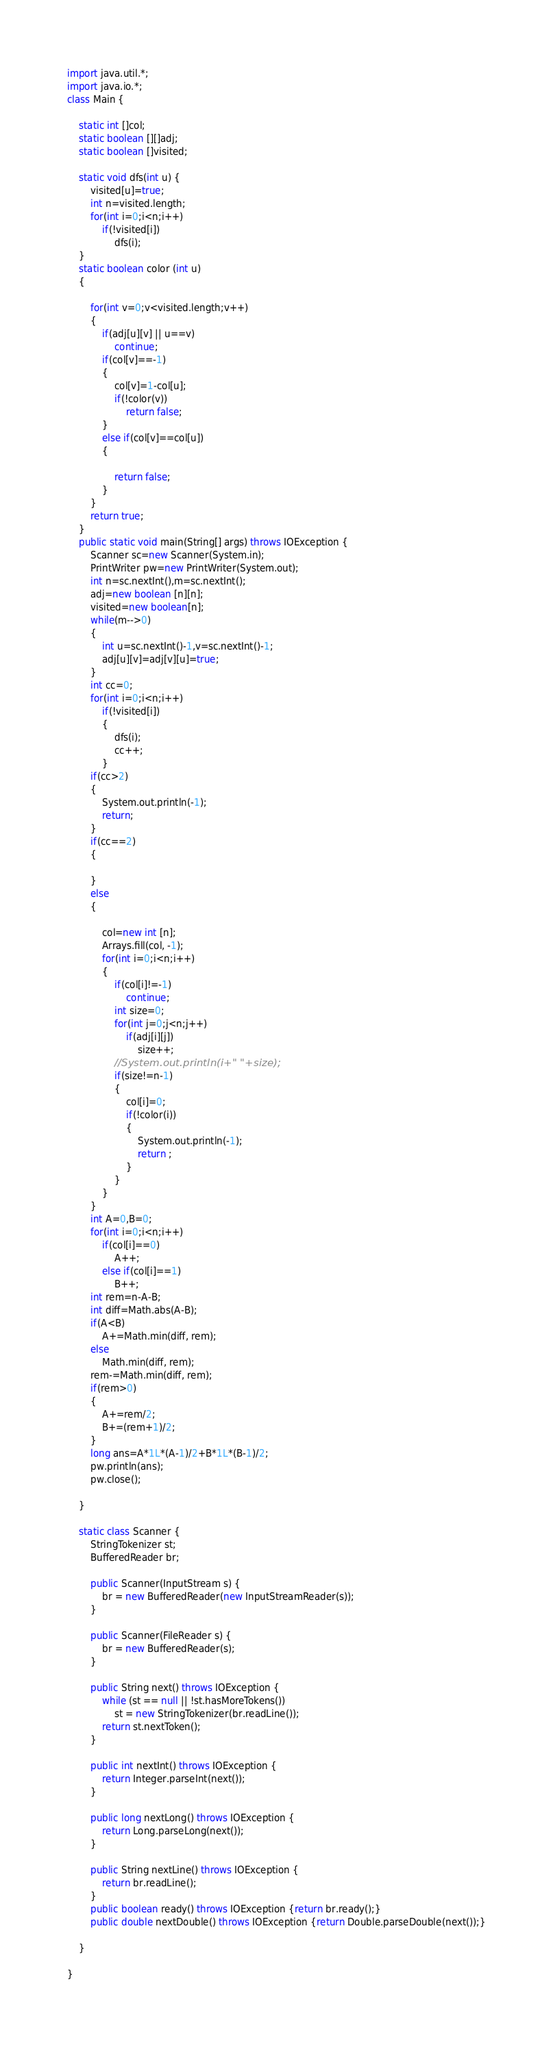Convert code to text. <code><loc_0><loc_0><loc_500><loc_500><_Java_>import java.util.*;
import java.io.*;
class Main {

	static int []col;
	static boolean [][]adj;
	static boolean []visited;
	
	static void dfs(int u) {
		visited[u]=true;
		int n=visited.length;
		for(int i=0;i<n;i++)
			if(!visited[i])
				dfs(i);
	}
	static boolean color (int u)
	{
		
		for(int v=0;v<visited.length;v++)
		{
			if(adj[u][v] || u==v)
				continue;
			if(col[v]==-1)
			{
				col[v]=1-col[u];
				if(!color(v))
					return false;
			}
			else if(col[v]==col[u])
			{
				
				return false;
			}	
		}
		return true;
	}
	public static void main(String[] args) throws IOException {
		Scanner sc=new Scanner(System.in);
		PrintWriter pw=new PrintWriter(System.out);
		int n=sc.nextInt(),m=sc.nextInt();
		adj=new boolean [n][n];
		visited=new boolean[n];
		while(m-->0)
		{
			int u=sc.nextInt()-1,v=sc.nextInt()-1;
			adj[u][v]=adj[v][u]=true;
		}
		int cc=0;
		for(int i=0;i<n;i++)
			if(!visited[i])
			{
				dfs(i);
				cc++;
			}
		if(cc>2)
		{
			System.out.println(-1);
			return;
		}
		if(cc==2)
		{
			
		}
		else
		{
			
			col=new int [n];
			Arrays.fill(col, -1);
			for(int i=0;i<n;i++)
			{
				if(col[i]!=-1)
					continue;
				int size=0;
				for(int j=0;j<n;j++)
					if(adj[i][j])
						size++;
				//System.out.println(i+" "+size);
				if(size!=n-1)
				{
					col[i]=0;
					if(!color(i))
					{
						System.out.println(-1);
						return ;
					}
				}
			}
		}
		int A=0,B=0;
		for(int i=0;i<n;i++)
			if(col[i]==0)
				A++;
			else if(col[i]==1)
				B++;
		int rem=n-A-B;
		int diff=Math.abs(A-B);
		if(A<B)
			A+=Math.min(diff, rem);
		else
			Math.min(diff, rem);
		rem-=Math.min(diff, rem);
		if(rem>0)
		{
			A+=rem/2;
			B+=(rem+1)/2;
		}
		long ans=A*1L*(A-1)/2+B*1L*(B-1)/2;
		pw.println(ans);
		pw.close();
		
	}
	
	static class Scanner {
        StringTokenizer st;
        BufferedReader br;
 
        public Scanner(InputStream s) {
            br = new BufferedReader(new InputStreamReader(s));
        }
 
        public Scanner(FileReader s) {
            br = new BufferedReader(s);
        }
 
        public String next() throws IOException {
            while (st == null || !st.hasMoreTokens())
                st = new StringTokenizer(br.readLine());
            return st.nextToken();
        }
 
        public int nextInt() throws IOException {
            return Integer.parseInt(next());
        }
 
        public long nextLong() throws IOException {
            return Long.parseLong(next());
        }
 
        public String nextLine() throws IOException {
            return br.readLine();
        }
        public boolean ready() throws IOException {return br.ready();}
        public double nextDouble() throws IOException {return Double.parseDouble(next());}
       
    }

}</code> 